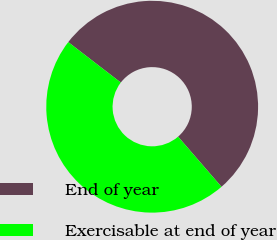Convert chart to OTSL. <chart><loc_0><loc_0><loc_500><loc_500><pie_chart><fcel>End of year<fcel>Exercisable at end of year<nl><fcel>53.21%<fcel>46.79%<nl></chart> 